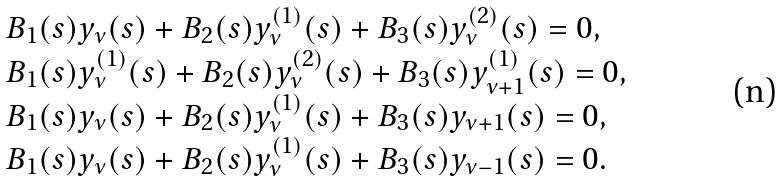Convert formula to latex. <formula><loc_0><loc_0><loc_500><loc_500>\begin{array} { l l l l } & B _ { 1 } ( s ) y _ { \nu } ( s ) + B _ { 2 } ( s ) y ^ { ( 1 ) } _ { \nu } ( s ) + B _ { 3 } ( s ) y ^ { ( 2 ) } _ { \nu } ( s ) = 0 , \\ & B _ { 1 } ( s ) y ^ { ( 1 ) } _ { \nu } ( s ) + B _ { 2 } ( s ) y ^ { ( 2 ) } _ { \nu } ( s ) + B _ { 3 } ( s ) y ^ { ( 1 ) } _ { \nu + 1 } ( s ) = 0 , \\ & B _ { 1 } ( s ) y _ { \nu } ( s ) + B _ { 2 } ( s ) y ^ { ( 1 ) } _ { \nu } ( s ) + B _ { 3 } ( s ) y _ { \nu + 1 } ( s ) = 0 , \\ & B _ { 1 } ( s ) y _ { \nu } ( s ) + B _ { 2 } ( s ) y ^ { ( 1 ) } _ { \nu } ( s ) + B _ { 3 } ( s ) y _ { \nu - 1 } ( s ) = 0 . \end{array}</formula> 